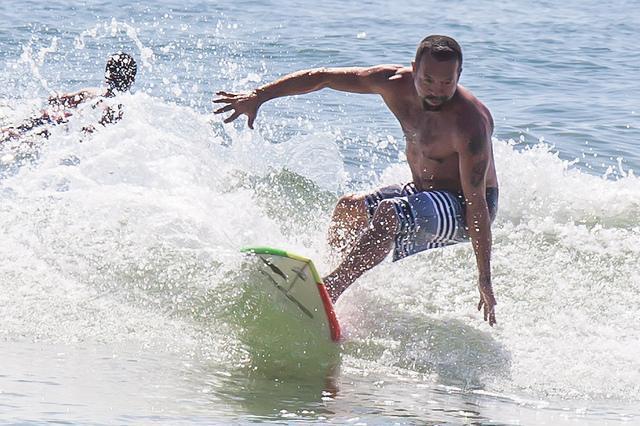What is the surfer doing to the wave?
From the following set of four choices, select the accurate answer to respond to the question.
Options: Splitting, carving, cutting, slicing. Carving. 